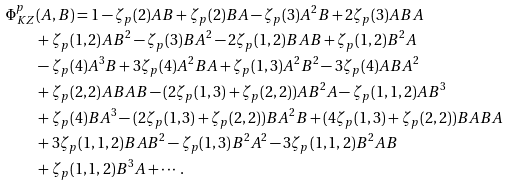<formula> <loc_0><loc_0><loc_500><loc_500>\Phi ^ { p } _ { K Z } & ( A , B ) = 1 - \zeta _ { p } ( 2 ) A B + \zeta _ { p } ( 2 ) B A - \zeta _ { p } ( 3 ) A ^ { 2 } B + 2 \zeta _ { p } ( 3 ) A B A \\ & + \zeta _ { p } ( 1 , 2 ) A B ^ { 2 } - \zeta _ { p } ( 3 ) B A ^ { 2 } - 2 \zeta _ { p } ( 1 , 2 ) B A B + \zeta _ { p } ( 1 , 2 ) B ^ { 2 } A \\ & - \zeta _ { p } ( 4 ) A ^ { 3 } B + 3 \zeta _ { p } ( 4 ) A ^ { 2 } B A + \zeta _ { p } ( 1 , 3 ) A ^ { 2 } B ^ { 2 } - 3 \zeta _ { p } ( 4 ) A B A ^ { 2 } \\ & + \zeta _ { p } ( 2 , 2 ) A B A B - ( 2 \zeta _ { p } ( 1 , 3 ) + \zeta _ { p } ( 2 , 2 ) ) A B ^ { 2 } A - \zeta _ { p } ( 1 , 1 , 2 ) A B ^ { 3 } \\ & + \zeta _ { p } ( 4 ) B A ^ { 3 } - ( 2 \zeta _ { p } ( 1 , 3 ) + \zeta _ { p } ( 2 , 2 ) ) B A ^ { 2 } B + ( 4 \zeta _ { p } ( 1 , 3 ) + \zeta _ { p } ( 2 , 2 ) ) B A B A \\ & + 3 \zeta _ { p } ( 1 , 1 , 2 ) B A B ^ { 2 } - \zeta _ { p } ( 1 , 3 ) B ^ { 2 } A ^ { 2 } - 3 \zeta _ { p } ( 1 , 1 , 2 ) B ^ { 2 } A B \\ & + \zeta _ { p } ( 1 , 1 , 2 ) B ^ { 3 } A + \cdots .</formula> 